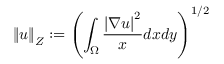<formula> <loc_0><loc_0><loc_500><loc_500>\left \| u \right \| _ { Z } \colon = \left ( \int _ { \Omega } \frac { \left | \nabla u \right | ^ { 2 } } { x } d x d y \right ) ^ { 1 / 2 }</formula> 